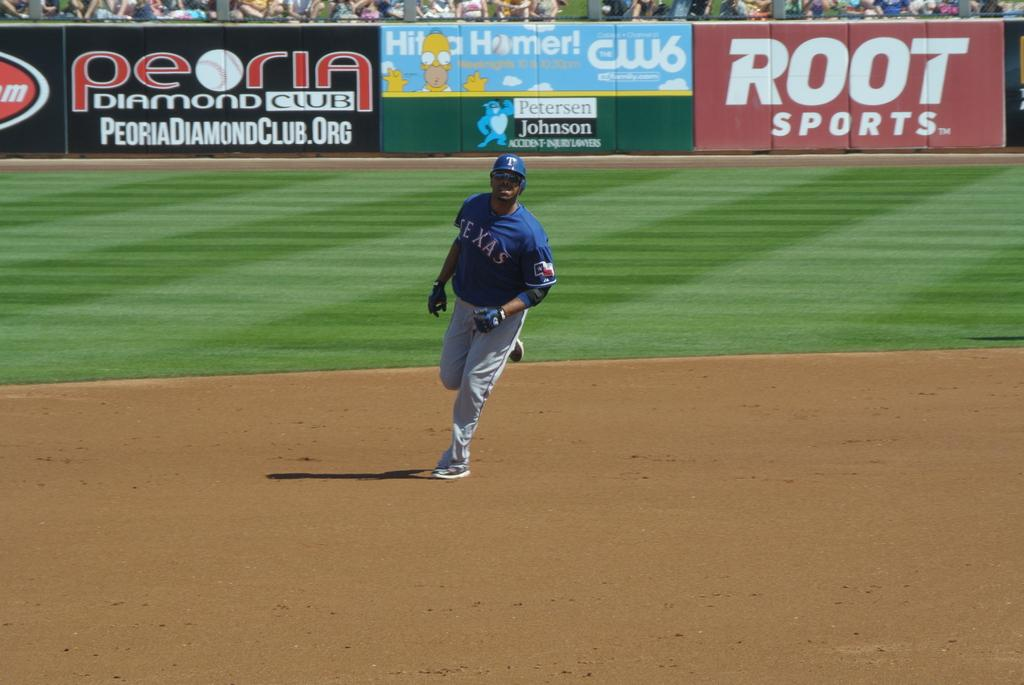<image>
Give a short and clear explanation of the subsequent image. Man wearing a blue Texas jersey standing on the field. 